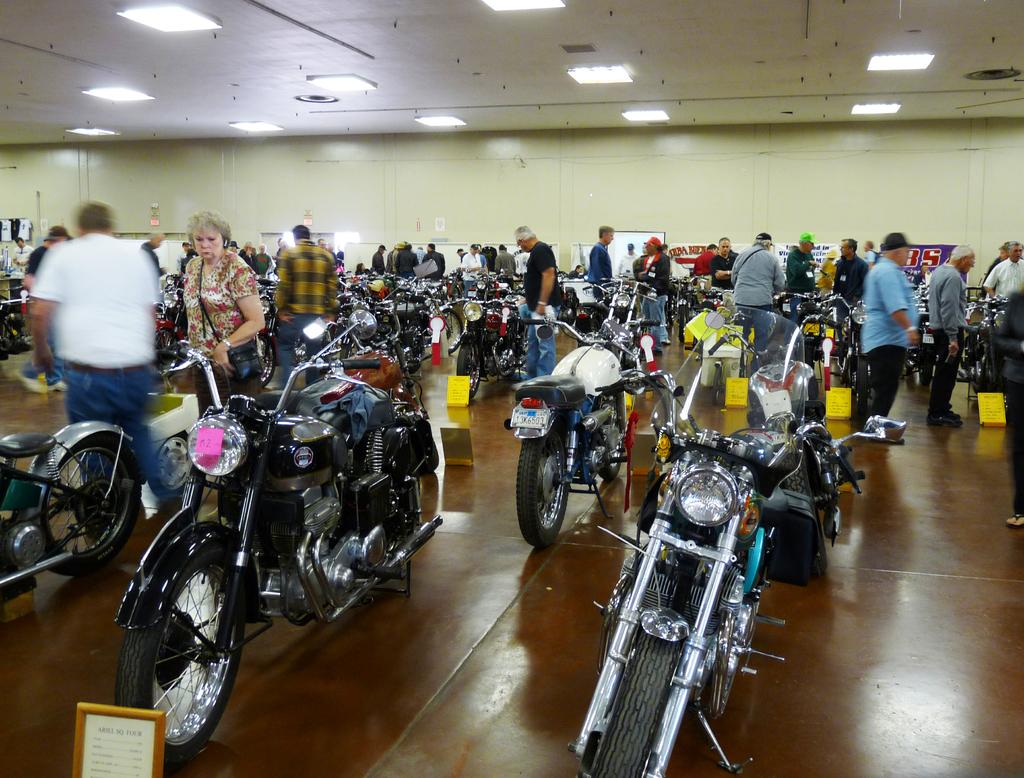What type of event is taking place in the image? The image appears to be a motorcycle exhibition. What are the people in the image doing? There are people standing and watching the motorcycles. Can you describe any specific features of the exhibition area? There is a roof with a lightning arrangement. What is the tax rate for the motorcycles on display in the image? There is no information about tax rates in the image, as it focuses on the motorcycle exhibition and the people attending it. 